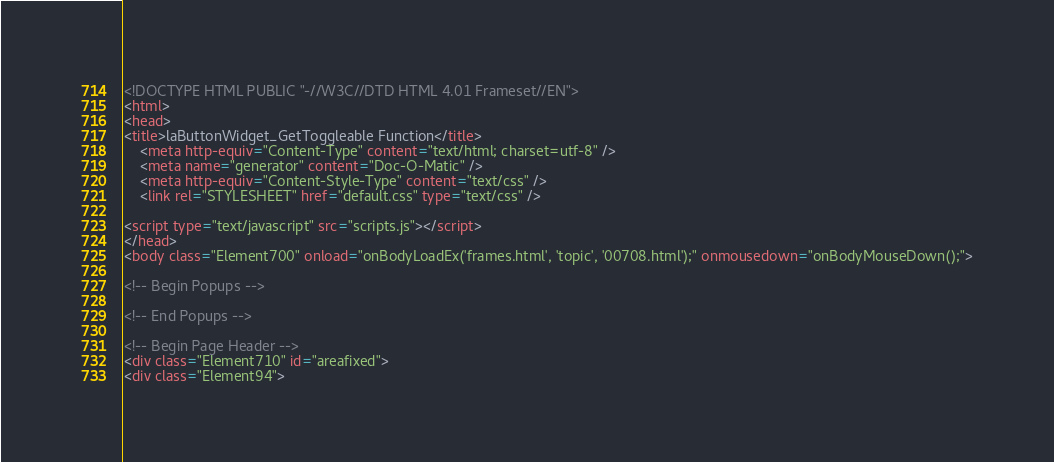<code> <loc_0><loc_0><loc_500><loc_500><_HTML_><!DOCTYPE HTML PUBLIC "-//W3C//DTD HTML 4.01 Frameset//EN">
<html>
<head>
<title>laButtonWidget_GetToggleable Function</title>
    <meta http-equiv="Content-Type" content="text/html; charset=utf-8" />
    <meta name="generator" content="Doc-O-Matic" />
    <meta http-equiv="Content-Style-Type" content="text/css" />
    <link rel="STYLESHEET" href="default.css" type="text/css" />

<script type="text/javascript" src="scripts.js"></script>
</head>
<body class="Element700" onload="onBodyLoadEx('frames.html', 'topic', '00708.html');" onmousedown="onBodyMouseDown();">

<!-- Begin Popups -->

<!-- End Popups -->

<!-- Begin Page Header -->
<div class="Element710" id="areafixed">
<div class="Element94"></code> 